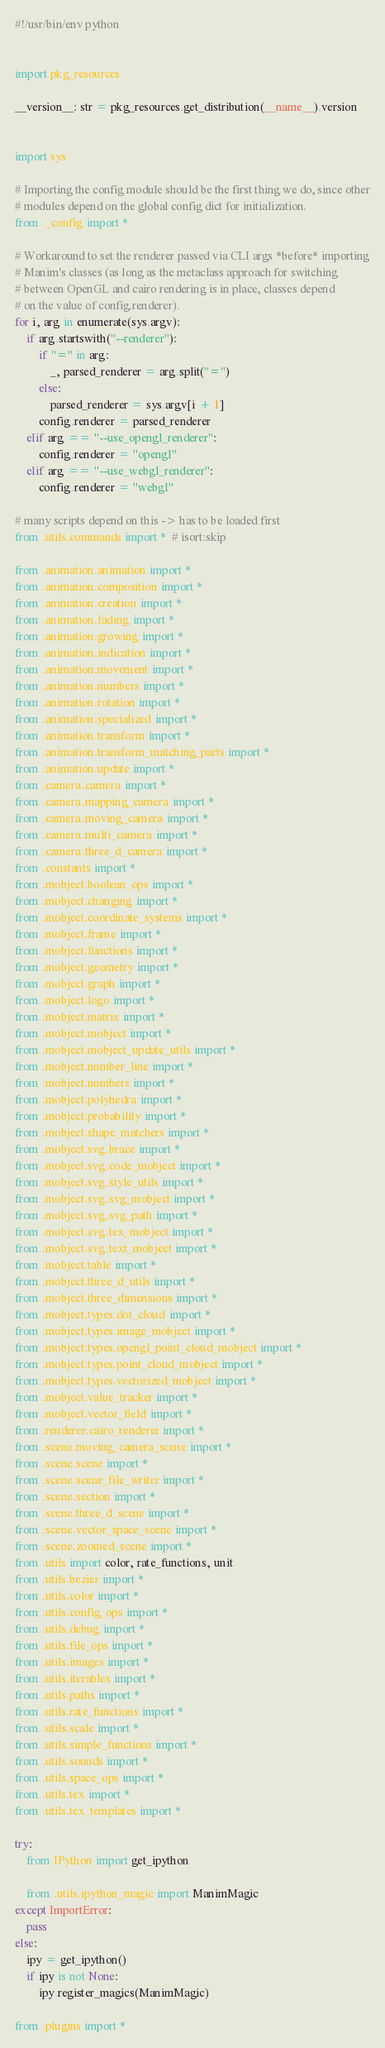<code> <loc_0><loc_0><loc_500><loc_500><_Python_>#!/usr/bin/env python


import pkg_resources

__version__: str = pkg_resources.get_distribution(__name__).version


import sys

# Importing the config module should be the first thing we do, since other
# modules depend on the global config dict for initialization.
from ._config import *

# Workaround to set the renderer passed via CLI args *before* importing
# Manim's classes (as long as the metaclass approach for switching
# between OpenGL and cairo rendering is in place, classes depend
# on the value of config.renderer).
for i, arg in enumerate(sys.argv):
    if arg.startswith("--renderer"):
        if "=" in arg:
            _, parsed_renderer = arg.split("=")
        else:
            parsed_renderer = sys.argv[i + 1]
        config.renderer = parsed_renderer
    elif arg == "--use_opengl_renderer":
        config.renderer = "opengl"
    elif arg == "--use_webgl_renderer":
        config.renderer = "webgl"

# many scripts depend on this -> has to be loaded first
from .utils.commands import *  # isort:skip

from .animation.animation import *
from .animation.composition import *
from .animation.creation import *
from .animation.fading import *
from .animation.growing import *
from .animation.indication import *
from .animation.movement import *
from .animation.numbers import *
from .animation.rotation import *
from .animation.specialized import *
from .animation.transform import *
from .animation.transform_matching_parts import *
from .animation.update import *
from .camera.camera import *
from .camera.mapping_camera import *
from .camera.moving_camera import *
from .camera.multi_camera import *
from .camera.three_d_camera import *
from .constants import *
from .mobject.boolean_ops import *
from .mobject.changing import *
from .mobject.coordinate_systems import *
from .mobject.frame import *
from .mobject.functions import *
from .mobject.geometry import *
from .mobject.graph import *
from .mobject.logo import *
from .mobject.matrix import *
from .mobject.mobject import *
from .mobject.mobject_update_utils import *
from .mobject.number_line import *
from .mobject.numbers import *
from .mobject.polyhedra import *
from .mobject.probability import *
from .mobject.shape_matchers import *
from .mobject.svg.brace import *
from .mobject.svg.code_mobject import *
from .mobject.svg.style_utils import *
from .mobject.svg.svg_mobject import *
from .mobject.svg.svg_path import *
from .mobject.svg.tex_mobject import *
from .mobject.svg.text_mobject import *
from .mobject.table import *
from .mobject.three_d_utils import *
from .mobject.three_dimensions import *
from .mobject.types.dot_cloud import *
from .mobject.types.image_mobject import *
from .mobject.types.opengl_point_cloud_mobject import *
from .mobject.types.point_cloud_mobject import *
from .mobject.types.vectorized_mobject import *
from .mobject.value_tracker import *
from .mobject.vector_field import *
from .renderer.cairo_renderer import *
from .scene.moving_camera_scene import *
from .scene.scene import *
from .scene.scene_file_writer import *
from .scene.section import *
from .scene.three_d_scene import *
from .scene.vector_space_scene import *
from .scene.zoomed_scene import *
from .utils import color, rate_functions, unit
from .utils.bezier import *
from .utils.color import *
from .utils.config_ops import *
from .utils.debug import *
from .utils.file_ops import *
from .utils.images import *
from .utils.iterables import *
from .utils.paths import *
from .utils.rate_functions import *
from .utils.scale import *
from .utils.simple_functions import *
from .utils.sounds import *
from .utils.space_ops import *
from .utils.tex import *
from .utils.tex_templates import *

try:
    from IPython import get_ipython

    from .utils.ipython_magic import ManimMagic
except ImportError:
    pass
else:
    ipy = get_ipython()
    if ipy is not None:
        ipy.register_magics(ManimMagic)

from .plugins import *
</code> 